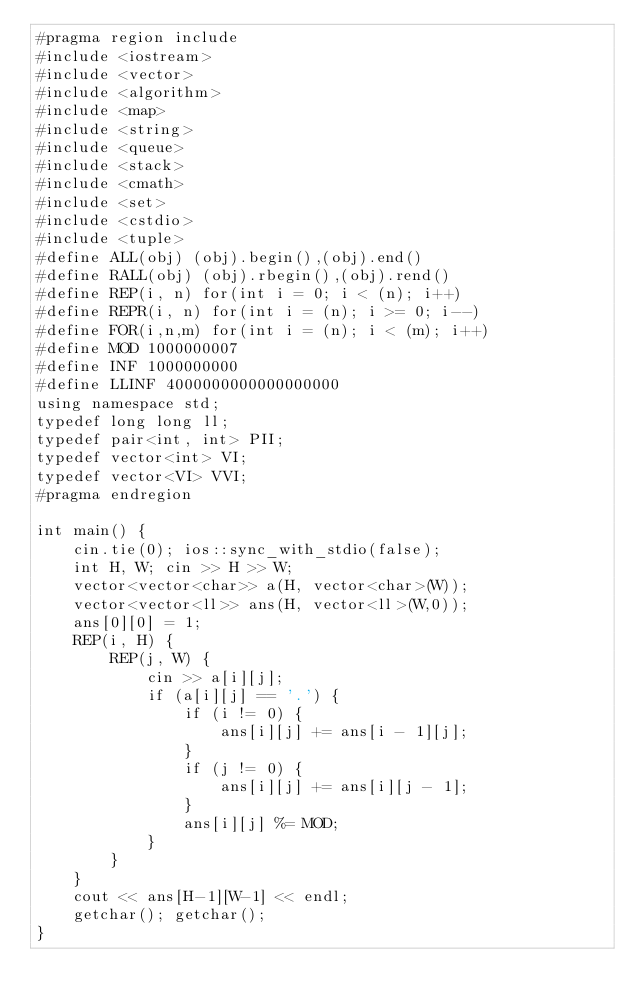Convert code to text. <code><loc_0><loc_0><loc_500><loc_500><_C++_>#pragma region include
#include <iostream>
#include <vector>
#include <algorithm>
#include <map>
#include <string>
#include <queue>
#include <stack>
#include <cmath>
#include <set>
#include <cstdio>
#include <tuple>
#define ALL(obj) (obj).begin(),(obj).end()
#define RALL(obj) (obj).rbegin(),(obj).rend()
#define REP(i, n) for(int i = 0; i < (n); i++)
#define REPR(i, n) for(int i = (n); i >= 0; i--)
#define FOR(i,n,m) for(int i = (n); i < (m); i++)
#define MOD 1000000007
#define INF 1000000000
#define LLINF 4000000000000000000
using namespace std;
typedef long long ll;
typedef pair<int, int> PII;
typedef vector<int> VI;
typedef vector<VI> VVI;
#pragma endregion

int main() {
    cin.tie(0); ios::sync_with_stdio(false);
    int H, W; cin >> H >> W;
    vector<vector<char>> a(H, vector<char>(W));
    vector<vector<ll>> ans(H, vector<ll>(W,0));
    ans[0][0] = 1;
    REP(i, H) {
        REP(j, W) {
            cin >> a[i][j];
            if (a[i][j] == '.') {
                if (i != 0) {
                    ans[i][j] += ans[i - 1][j];
                }
                if (j != 0) {
                    ans[i][j] += ans[i][j - 1];
                }
                ans[i][j] %= MOD;
            }
        }
    }
    cout << ans[H-1][W-1] << endl;
    getchar(); getchar();
}</code> 